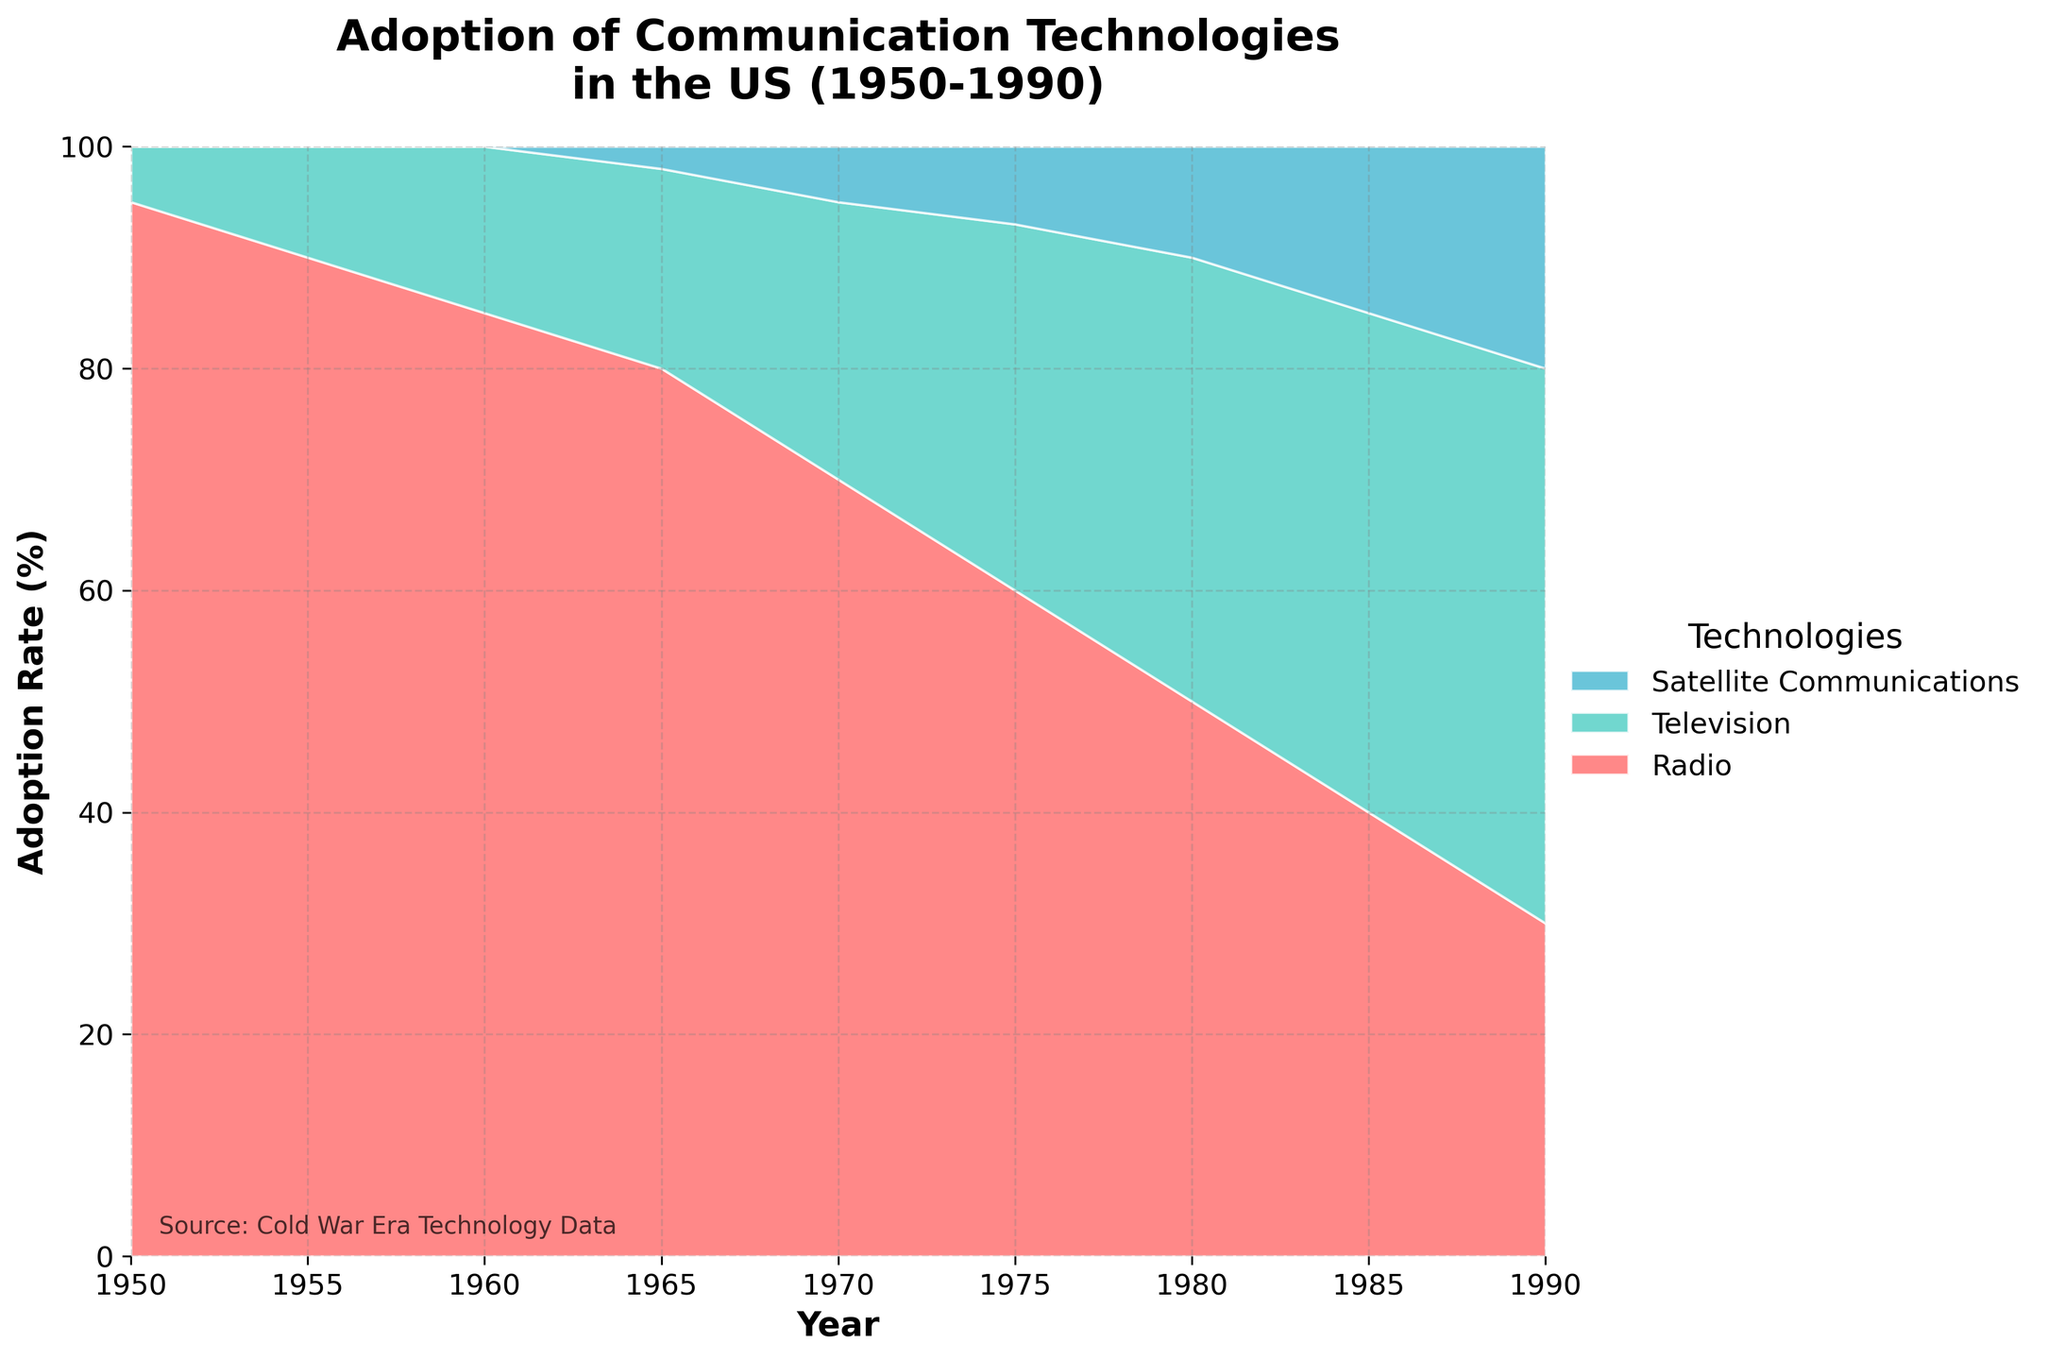What is the title of the chart? The chart's title is usually placed at the top and is written in a large, bold font.
Answer: Adoption of Communication Technologies in the US (1950-1990) What years does the chart cover? The horizontal axis (X-axis) represents the years; identifying the earliest and latest years will provide the range the chart covers.
Answer: 1950 to 1990 What technology had the highest adoption rate in 1980? Look at the 1980 mark on the X-axis and observe which section (color) is the largest percentage stack.
Answer: Television How did the adoption rate of satellite communications change from 1965 to 1990? Find the values for satellite communications at both years and calculate the difference. In 1965 it is 2% and in 1990 it is 20%.
Answer: Increased by 18% Compare the adoption rates of radio and television in 1975. Which was higher and by how much? Look at the specific values for radio and television in 1975 from the chart. Radio is 60%, and television is 33%; subtract to find the difference.
Answer: Radio was higher by 27% What was the approximate adoption rate of radio in 1990? Locate the section for radio on the stack in 1990 and estimate its height.
Answer: 30% If you sum the adoption rates of television and satellite communications in 1990, what is the total? Add the adoption rate percentages for television (50%) and satellite communications (20%) for 1990.
Answer: 70% Which technology showed a continuous decrease in adoption rates from 1950 to 1990? Identify the color section that consistently diminishes in size from left (1950) to right (1990).
Answer: Radio During which decade did television see the largest increase in adoption rate? Look for the steepest rise in the section representing television. The growth from the 1970s to the 1980s is significant.
Answer: 1970s Approximately what percentage of the market did radio and television together comprise in 1965? Add the adoption rates for radio (80%) and television (18%) in 1965.
Answer: 98% 